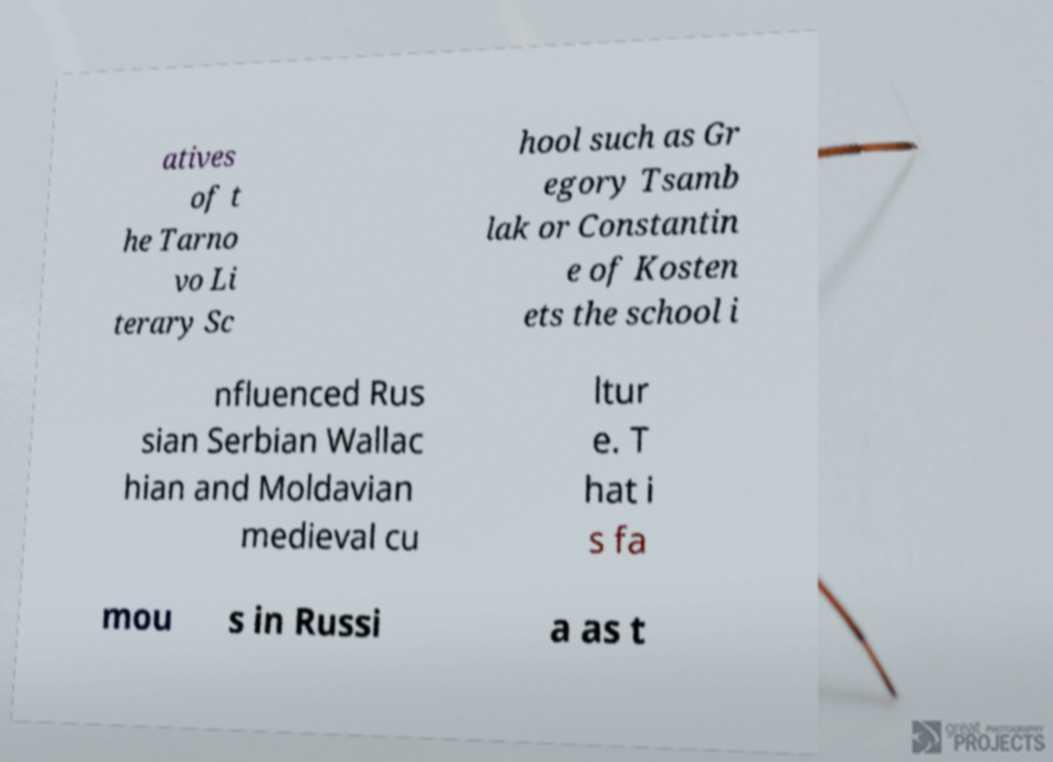Please read and relay the text visible in this image. What does it say? atives of t he Tarno vo Li terary Sc hool such as Gr egory Tsamb lak or Constantin e of Kosten ets the school i nfluenced Rus sian Serbian Wallac hian and Moldavian medieval cu ltur e. T hat i s fa mou s in Russi a as t 